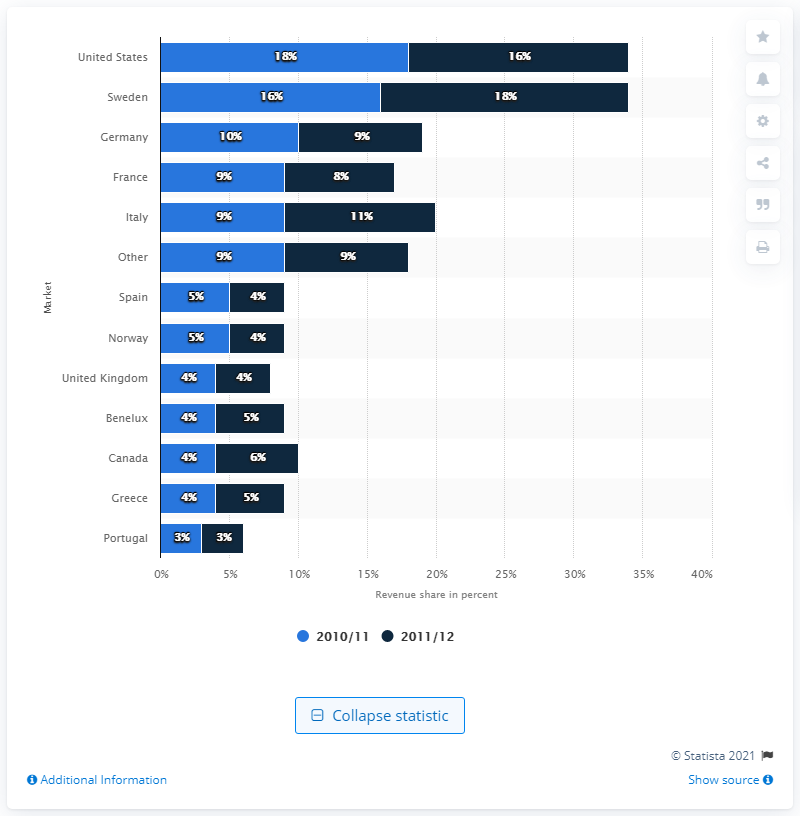Draw attention to some important aspects in this diagram. In the 2010/11 and 2011/12 fiscal years, the share of revenue generated by WESC in the German market was X%. 